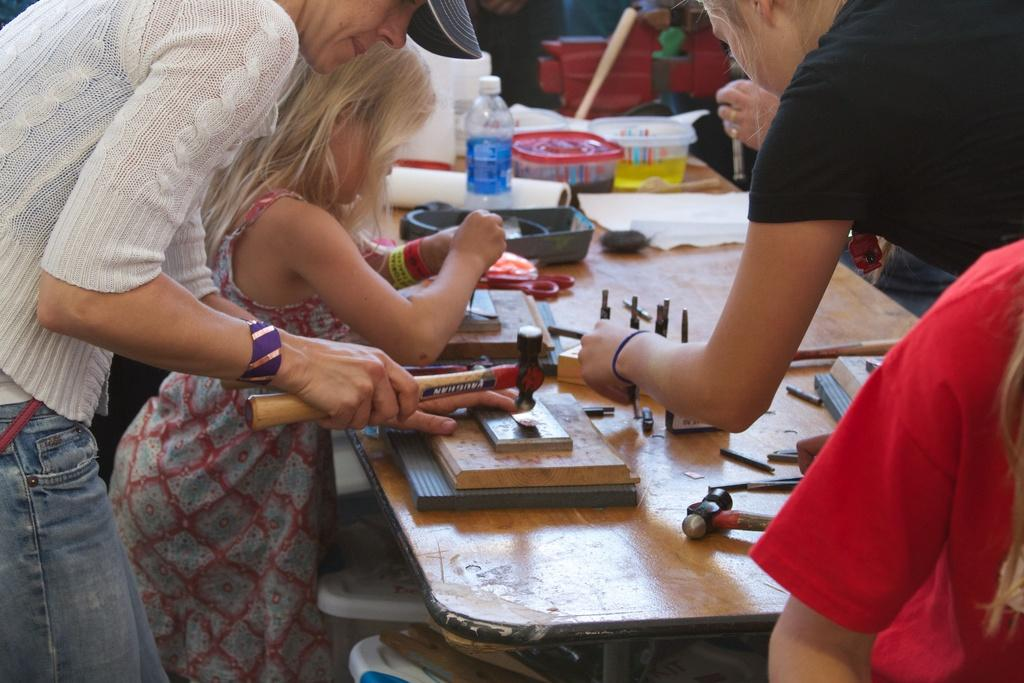How many people are in the image? There are people in the image, but the exact number is not specified. What are the people doing in the image? The people are standing and working on a table. What items can be seen on the table in the image? There is a water bottle, papers, boxes, wood, and cutting tools on the table. What type of sound can be heard coming from the middle of the table in the image? There is no information about any sound in the image, and the middle of the table is not specified. --- Facts: 1. There is a car in the image. 2. The car is parked on the street. 3. There are trees on the street. 4. There is a sidewalk next to the street. 5. There are streetlights on the street. Absurd Topics: parrot, dance, ocean Conversation: What is the main subject of the image? The main subject of the image is a car. Where is the car located in the image? The car is parked on the street. What other features can be seen on the street in the image? There are trees, a sidewalk, and streetlights on the street. Reasoning: Let's think step by step in order to produce the conversation. We start by identifying the main subject of the image, which is the car. Then, we describe the location of the car, which is parked on the street. Finally, we list the various features that are present on the street, as specified in the facts. Absurd Question/Answer: Can you see a parrot dancing on the ocean in the image? There is no mention of a parrot, dancing, or the ocean in the image. 